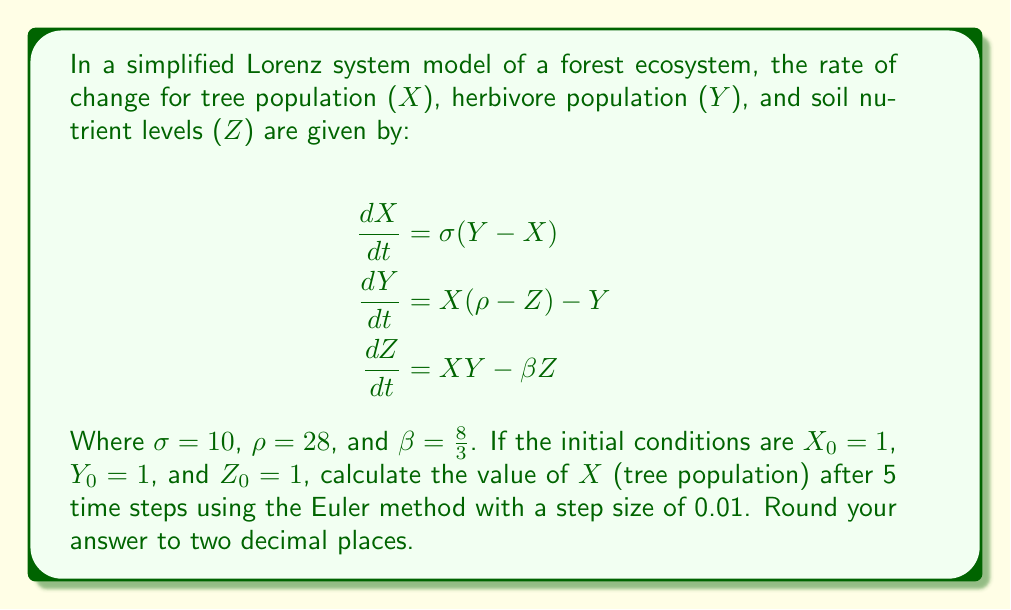What is the answer to this math problem? To solve this problem, we'll use the Euler method to approximate the solution of the Lorenz system. The Euler method is given by:

$$X_{n+1} = X_n + h \cdot f(X_n, Y_n, Z_n)$$
$$Y_{n+1} = Y_n + h \cdot g(X_n, Y_n, Z_n)$$
$$Z_{n+1} = Z_n + h \cdot k(X_n, Y_n, Z_n)$$

Where $h$ is the step size, and $f$, $g$, and $k$ are the right-hand sides of the differential equations.

Given:
- Initial conditions: $X_0 = 1$, $Y_0 = 1$, $Z_0 = 1$
- Step size: $h = 0.01$
- Number of steps: $5 / 0.01 = 500$

Let's calculate the first few steps:

Step 1:
$$X_1 = 1 + 0.01 \cdot 10(1 - 1) = 1$$
$$Y_1 = 1 + 0.01 \cdot [1(28 - 1) - 1] = 1.26$$
$$Z_1 = 1 + 0.01 \cdot [1 \cdot 1 - \frac{8}{3} \cdot 1] = 0.9733$$

Step 2:
$$X_2 = 1 + 0.01 \cdot 10(1.26 - 1) = 1.026$$
$$Y_2 = 1.26 + 0.01 \cdot [1.026(28 - 0.9733) - 1.26] = 1.5298$$
$$Z_2 = 0.9733 + 0.01 \cdot [1.026 \cdot 1.26 - \frac{8}{3} \cdot 0.9733] = 0.9503$$

We continue this process for 500 steps. After implementing this in a programming language or spreadsheet, we find that after 500 steps (5 time units):

$$X_{500} \approx 5.68$$

Rounding to two decimal places gives us 5.68.
Answer: 5.68 